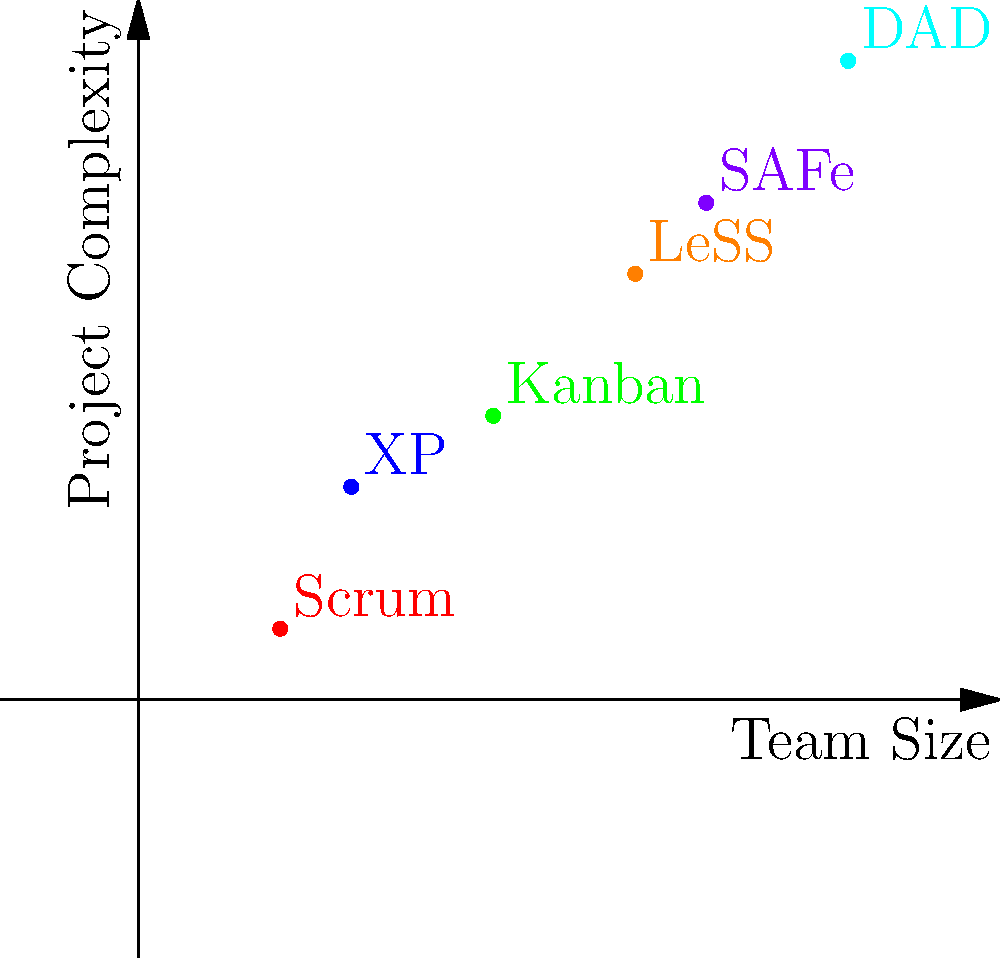Based on the scatter plot showing the relationship between team size and project complexity for different agile methodologies, which methodology appears to be most suitable for large, complex projects? To answer this question, we need to analyze the scatter plot and follow these steps:

1. Identify the axes: 
   - X-axis represents Team Size
   - Y-axis represents Project Complexity

2. Locate the data points for each agile methodology:
   - Scrum: small team, low complexity
   - XP (Extreme Programming): small team, low-medium complexity
   - Kanban: medium team, medium complexity
   - LeSS (Large-Scale Scrum): medium-large team, medium-high complexity
   - SAFe (Scaled Agile Framework): large team, high complexity
   - DAD (Disciplined Agile Delivery): largest team, highest complexity

3. Analyze the relationship:
   - As team size increases, project complexity tends to increase
   - Methodologies on the upper-right corner are suitable for larger, more complex projects

4. Identify the methodology in the upper-right corner:
   - DAD (Disciplined Agile Delivery) has the largest team size and highest project complexity

Therefore, based on this scatter plot, DAD appears to be the most suitable methodology for large, complex projects.
Answer: DAD (Disciplined Agile Delivery) 